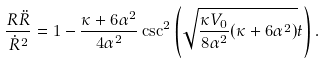<formula> <loc_0><loc_0><loc_500><loc_500>\frac { R \ddot { R } } { { \dot { R } } ^ { 2 } } = 1 - \frac { \kappa + 6 \alpha ^ { 2 } } { 4 \alpha ^ { 2 } } \csc ^ { 2 } \left ( \sqrt { \frac { \kappa V _ { 0 } } { 8 \alpha ^ { 2 } } ( \kappa + 6 \alpha ^ { 2 } ) } t \right ) .</formula> 